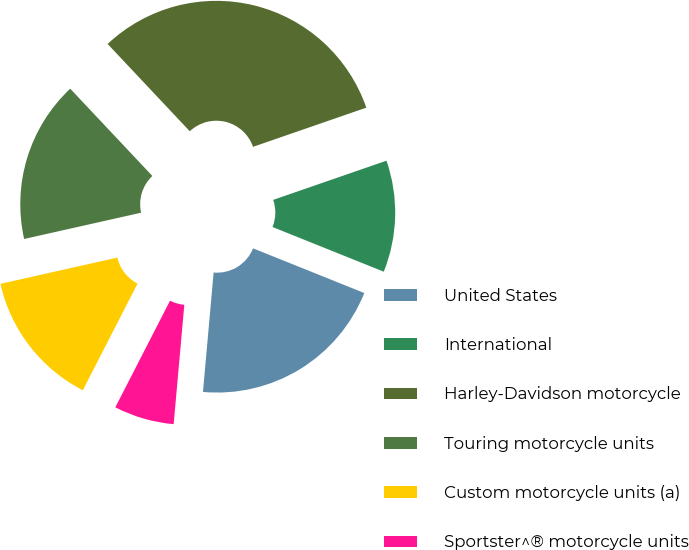Convert chart. <chart><loc_0><loc_0><loc_500><loc_500><pie_chart><fcel>United States<fcel>International<fcel>Harley-Davidson motorcycle<fcel>Touring motorcycle units<fcel>Custom motorcycle units (a)<fcel>Sportster^® motorcycle units<nl><fcel>20.34%<fcel>11.38%<fcel>31.72%<fcel>16.5%<fcel>13.94%<fcel>6.13%<nl></chart> 